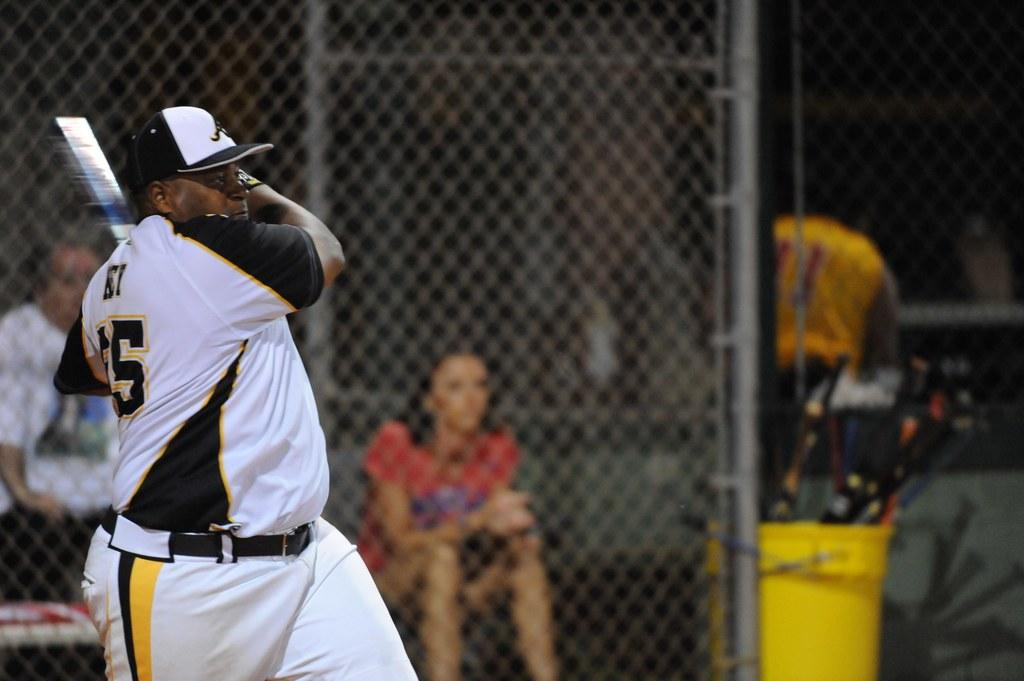<image>
Write a terse but informative summary of the picture. A baseball player wearing his number "5" jersey just swung his bat. 